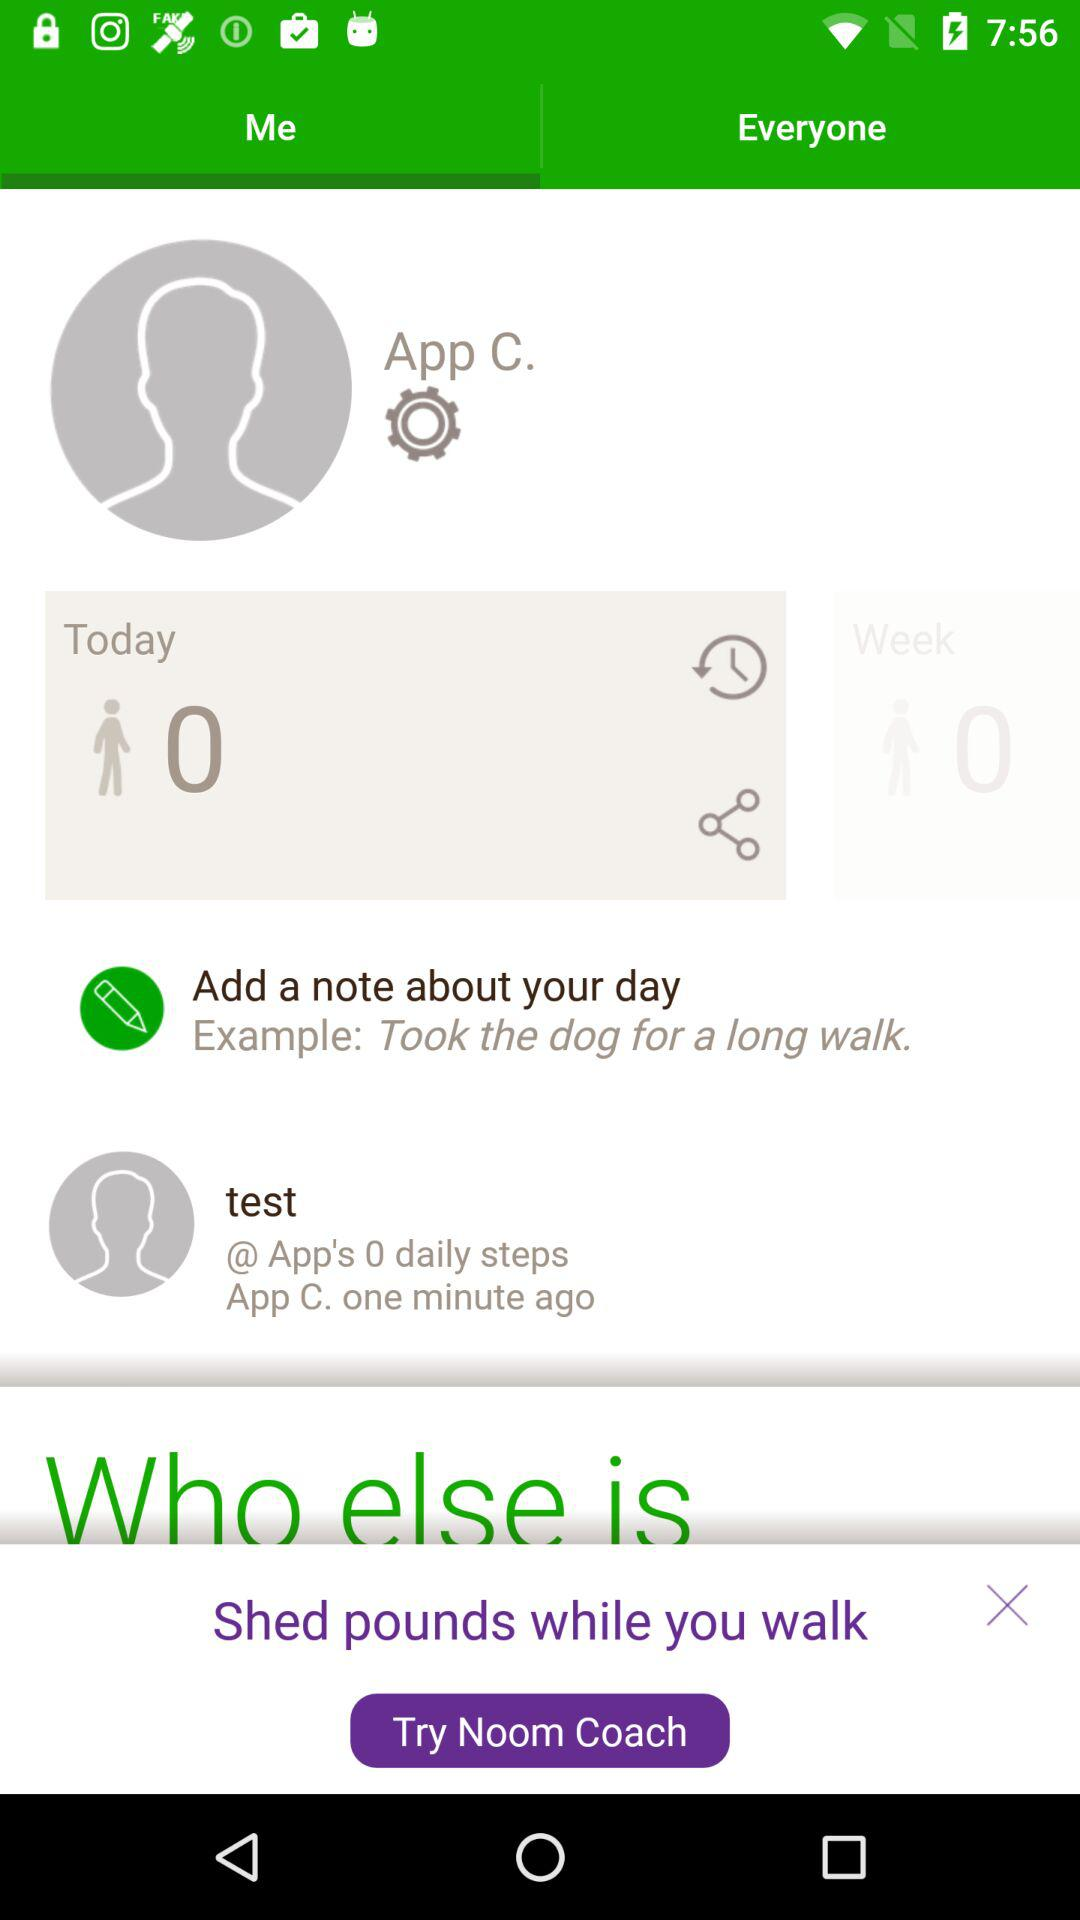Which tab is selected? The tab "Me" is selected. 